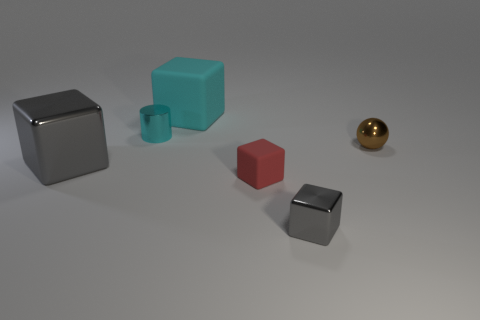Subtract all cyan cylinders. How many gray blocks are left? 2 Subtract all red cubes. How many cubes are left? 3 Subtract all red cubes. How many cubes are left? 3 Subtract 1 cubes. How many cubes are left? 3 Subtract all brown cubes. Subtract all gray spheres. How many cubes are left? 4 Add 4 large gray objects. How many objects exist? 10 Subtract all cylinders. How many objects are left? 5 Subtract 1 red cubes. How many objects are left? 5 Subtract all tiny rubber objects. Subtract all blue metal cubes. How many objects are left? 5 Add 4 large rubber blocks. How many large rubber blocks are left? 5 